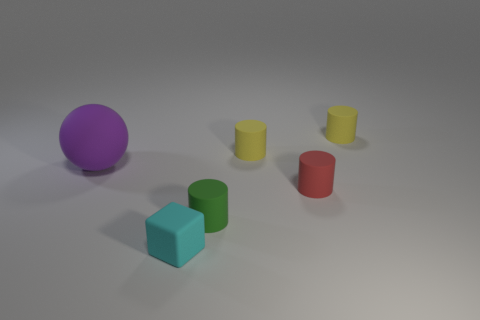Subtract all red cylinders. How many cylinders are left? 3 Subtract all red cylinders. How many cylinders are left? 3 Add 1 tiny blocks. How many objects exist? 7 Subtract all brown cylinders. How many blue cubes are left? 0 Subtract all green cylinders. Subtract all tiny rubber objects. How many objects are left? 0 Add 2 big rubber things. How many big rubber things are left? 3 Add 5 small cylinders. How many small cylinders exist? 9 Subtract 0 cyan cylinders. How many objects are left? 6 Subtract all spheres. How many objects are left? 5 Subtract 2 cylinders. How many cylinders are left? 2 